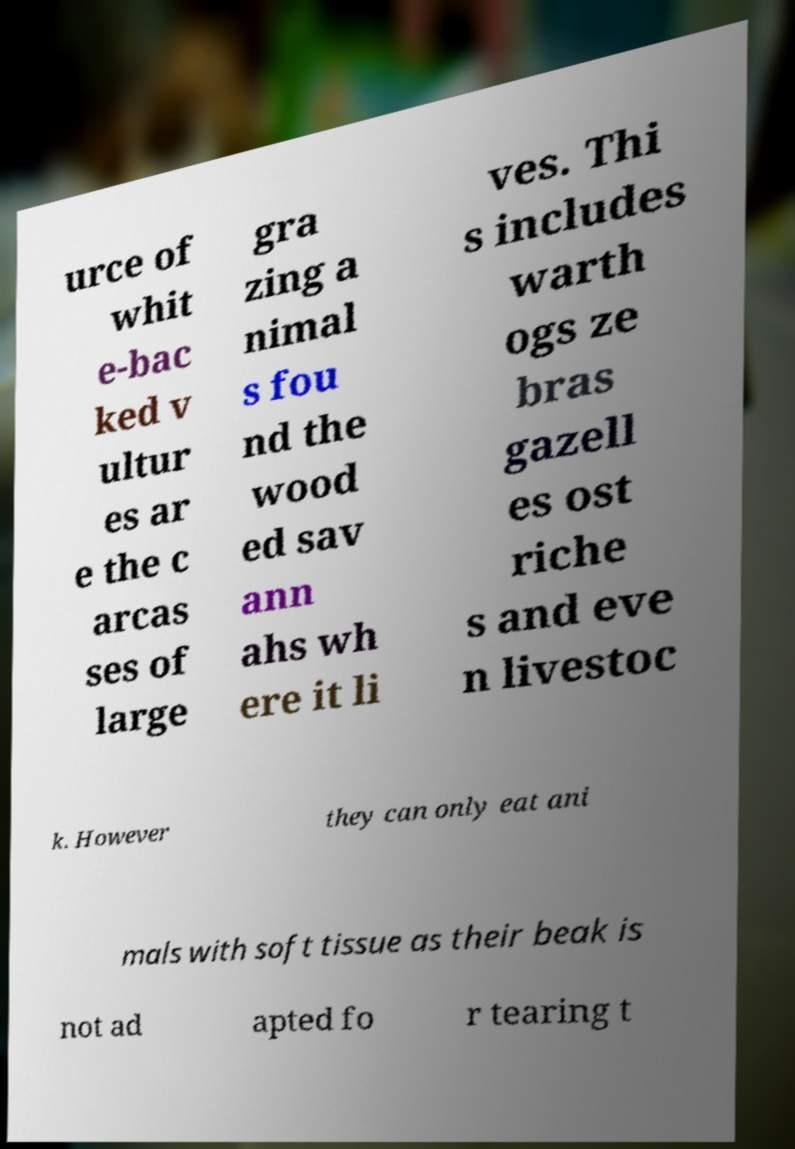For documentation purposes, I need the text within this image transcribed. Could you provide that? urce of whit e-bac ked v ultur es ar e the c arcas ses of large gra zing a nimal s fou nd the wood ed sav ann ahs wh ere it li ves. Thi s includes warth ogs ze bras gazell es ost riche s and eve n livestoc k. However they can only eat ani mals with soft tissue as their beak is not ad apted fo r tearing t 